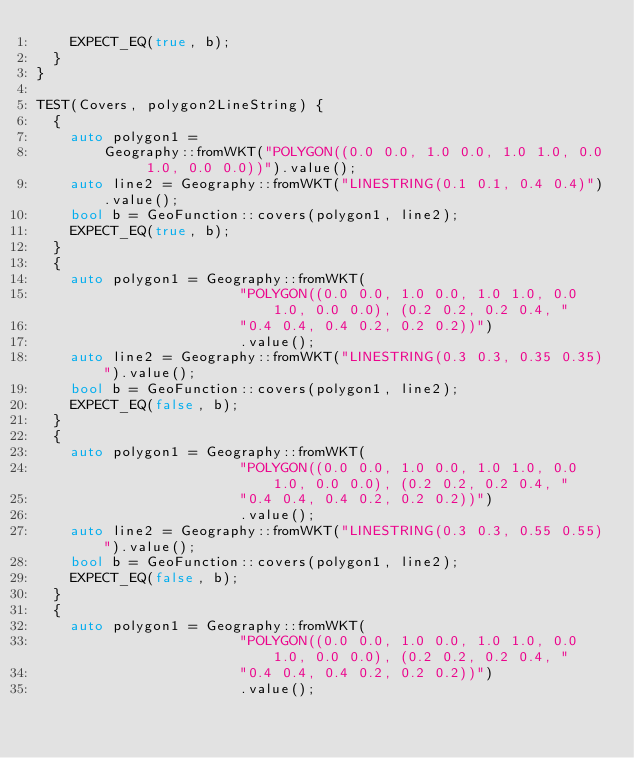Convert code to text. <code><loc_0><loc_0><loc_500><loc_500><_C++_>    EXPECT_EQ(true, b);
  }
}

TEST(Covers, polygon2LineString) {
  {
    auto polygon1 =
        Geography::fromWKT("POLYGON((0.0 0.0, 1.0 0.0, 1.0 1.0, 0.0 1.0, 0.0 0.0))").value();
    auto line2 = Geography::fromWKT("LINESTRING(0.1 0.1, 0.4 0.4)").value();
    bool b = GeoFunction::covers(polygon1, line2);
    EXPECT_EQ(true, b);
  }
  {
    auto polygon1 = Geography::fromWKT(
                        "POLYGON((0.0 0.0, 1.0 0.0, 1.0 1.0, 0.0 1.0, 0.0 0.0), (0.2 0.2, 0.2 0.4, "
                        "0.4 0.4, 0.4 0.2, 0.2 0.2))")
                        .value();
    auto line2 = Geography::fromWKT("LINESTRING(0.3 0.3, 0.35 0.35)").value();
    bool b = GeoFunction::covers(polygon1, line2);
    EXPECT_EQ(false, b);
  }
  {
    auto polygon1 = Geography::fromWKT(
                        "POLYGON((0.0 0.0, 1.0 0.0, 1.0 1.0, 0.0 1.0, 0.0 0.0), (0.2 0.2, 0.2 0.4, "
                        "0.4 0.4, 0.4 0.2, 0.2 0.2))")
                        .value();
    auto line2 = Geography::fromWKT("LINESTRING(0.3 0.3, 0.55 0.55)").value();
    bool b = GeoFunction::covers(polygon1, line2);
    EXPECT_EQ(false, b);
  }
  {
    auto polygon1 = Geography::fromWKT(
                        "POLYGON((0.0 0.0, 1.0 0.0, 1.0 1.0, 0.0 1.0, 0.0 0.0), (0.2 0.2, 0.2 0.4, "
                        "0.4 0.4, 0.4 0.2, 0.2 0.2))")
                        .value();</code> 